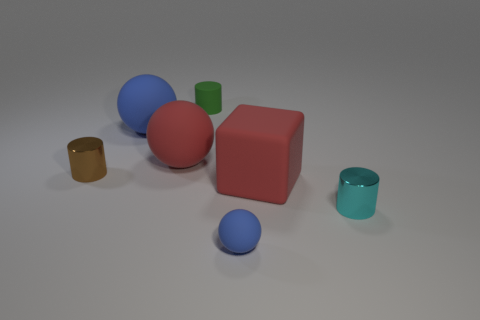What is the material of the big block?
Ensure brevity in your answer.  Rubber. Is the color of the tiny matte cylinder the same as the tiny cylinder to the left of the green matte cylinder?
Your response must be concise. No. How many spheres are either large red rubber objects or large blue objects?
Your answer should be compact. 2. There is a object that is in front of the small cyan metal thing; what is its color?
Provide a short and direct response. Blue. The rubber thing that is the same color as the rubber block is what shape?
Offer a terse response. Sphere. What number of brown shiny objects have the same size as the rubber cylinder?
Your answer should be compact. 1. Do the blue matte thing that is behind the matte cube and the large red rubber object left of the green rubber thing have the same shape?
Make the answer very short. Yes. There is a blue sphere that is behind the cylinder that is on the left side of the big red object to the left of the red rubber block; what is it made of?
Keep it short and to the point. Rubber. What shape is the green thing that is the same size as the cyan thing?
Make the answer very short. Cylinder. Are there any objects of the same color as the large cube?
Ensure brevity in your answer.  Yes. 